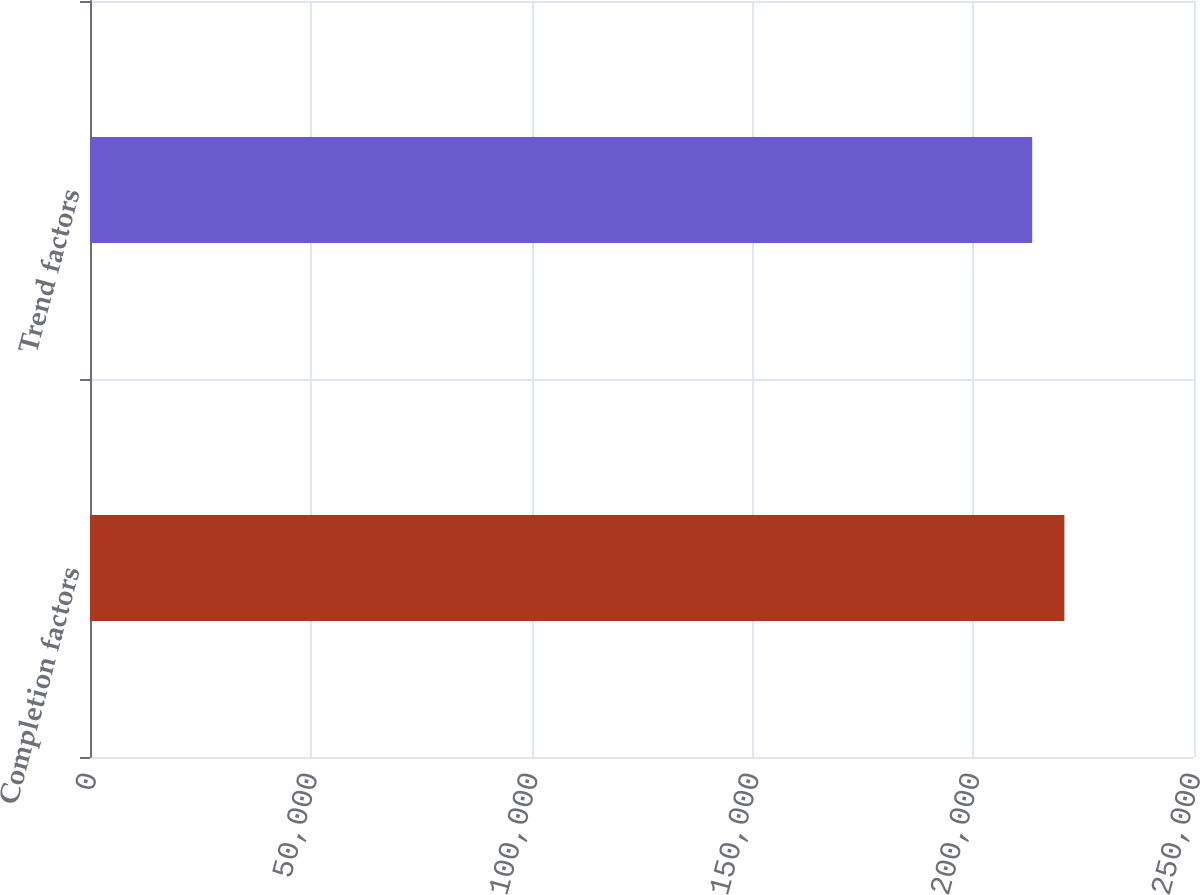Convert chart. <chart><loc_0><loc_0><loc_500><loc_500><bar_chart><fcel>Completion factors<fcel>Trend factors<nl><fcel>220653<fcel>213362<nl></chart> 